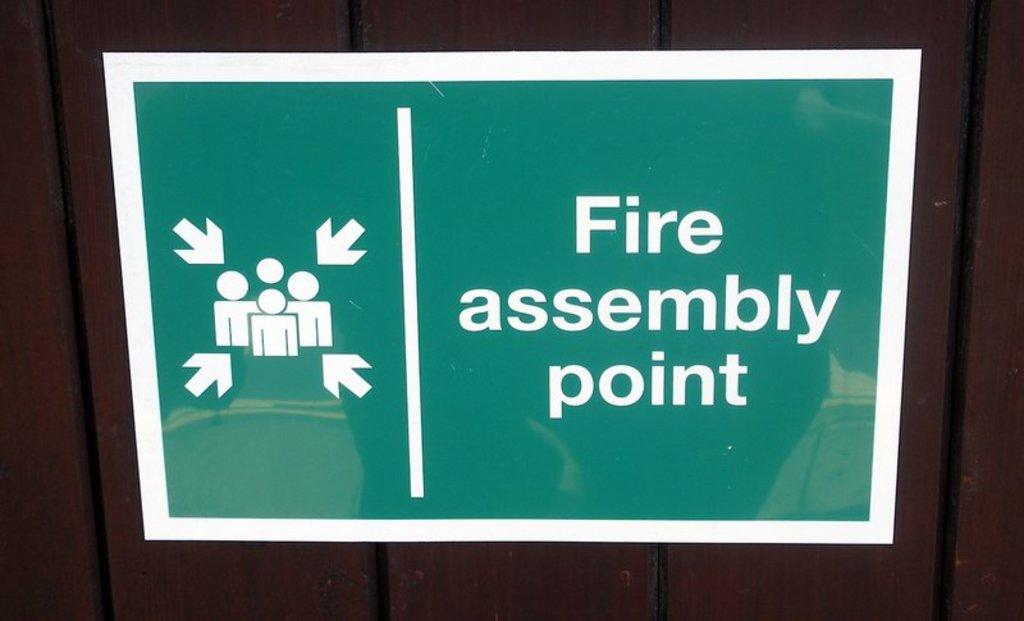<image>
Describe the image concisely. A green sign with a white border pointing at people letting them know that this is the Fire assembly point. 